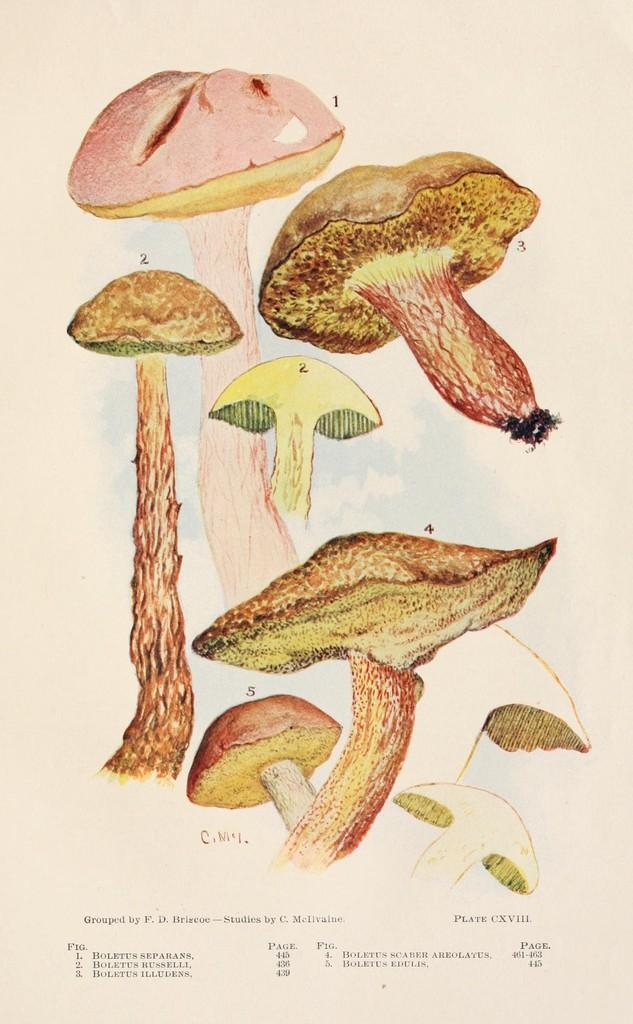What type of fungi can be seen in the image? There are mushrooms in the image. What else is present in the image besides the mushrooms? There is text on a page in the image. How many cats are sitting on the text in the image? There are no cats present in the image. What type of error can be seen in the text in the image? There is no error visible in the text in the image. 